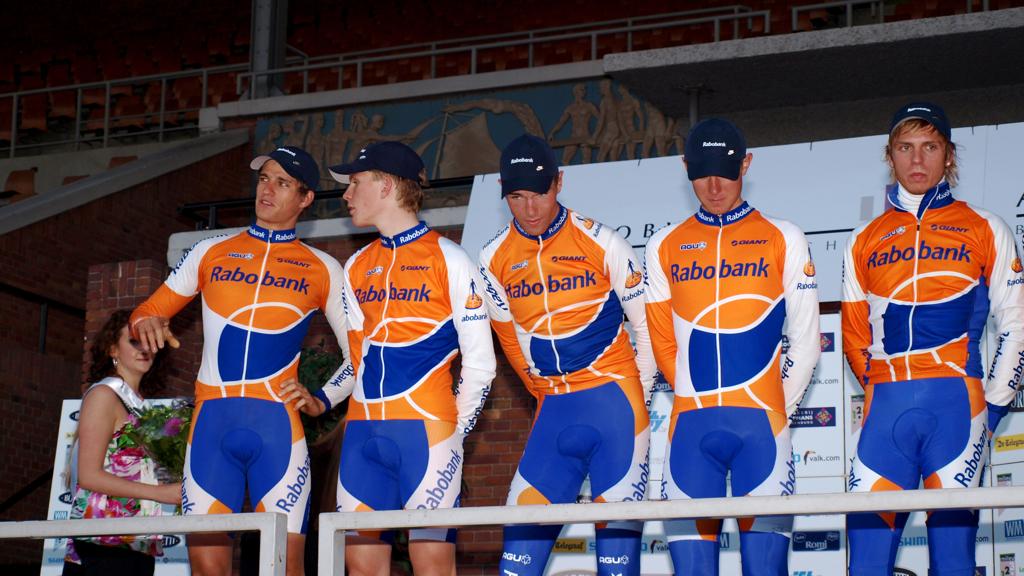What company sponsored the team?
Offer a terse response. Rabo bank. 